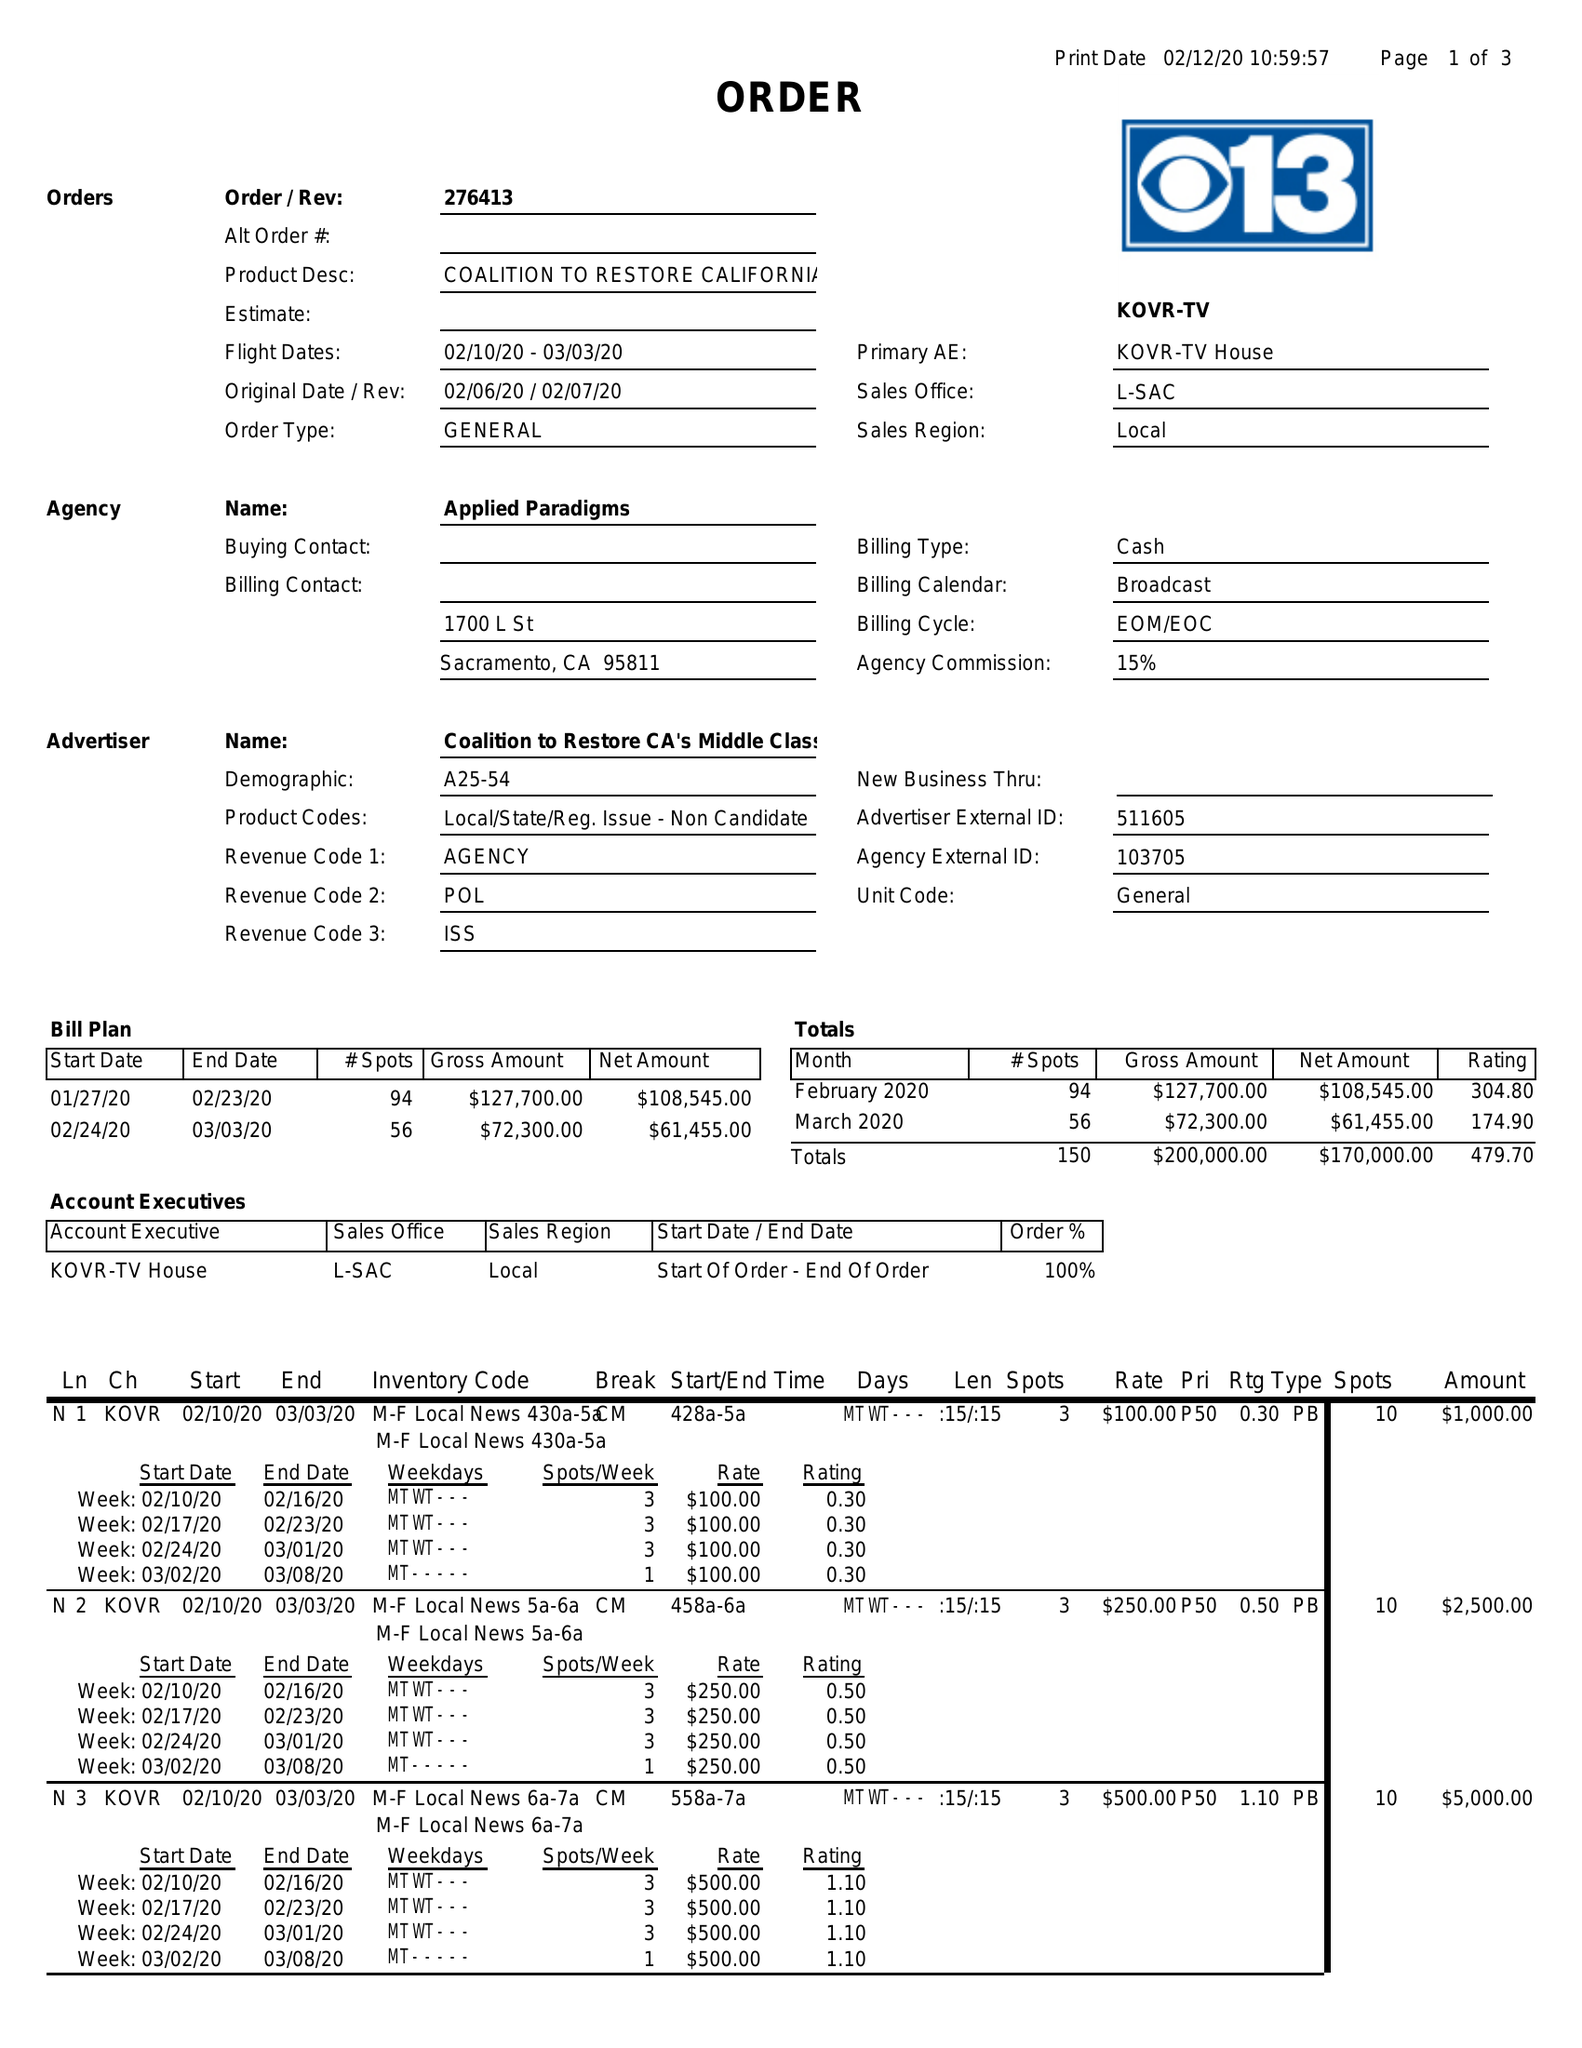What is the value for the gross_amount?
Answer the question using a single word or phrase. 200000.00 